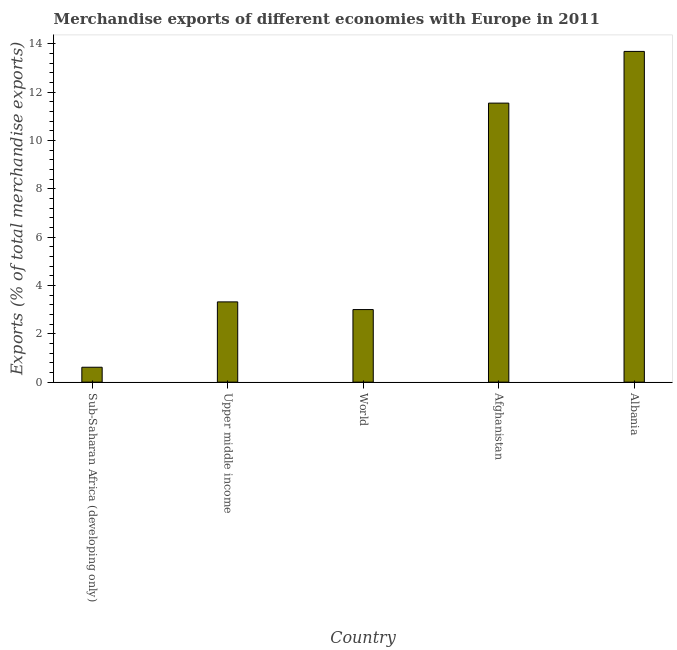Does the graph contain any zero values?
Give a very brief answer. No. What is the title of the graph?
Your answer should be very brief. Merchandise exports of different economies with Europe in 2011. What is the label or title of the X-axis?
Your response must be concise. Country. What is the label or title of the Y-axis?
Offer a terse response. Exports (% of total merchandise exports). What is the merchandise exports in Afghanistan?
Keep it short and to the point. 11.55. Across all countries, what is the maximum merchandise exports?
Ensure brevity in your answer.  13.69. Across all countries, what is the minimum merchandise exports?
Your response must be concise. 0.62. In which country was the merchandise exports maximum?
Your answer should be very brief. Albania. In which country was the merchandise exports minimum?
Provide a succinct answer. Sub-Saharan Africa (developing only). What is the sum of the merchandise exports?
Offer a very short reply. 32.17. What is the difference between the merchandise exports in Albania and World?
Provide a succinct answer. 10.68. What is the average merchandise exports per country?
Provide a succinct answer. 6.43. What is the median merchandise exports?
Your answer should be compact. 3.32. What is the ratio of the merchandise exports in Afghanistan to that in World?
Provide a succinct answer. 3.85. Is the difference between the merchandise exports in Albania and Upper middle income greater than the difference between any two countries?
Provide a short and direct response. No. What is the difference between the highest and the second highest merchandise exports?
Your answer should be very brief. 2.14. Is the sum of the merchandise exports in Afghanistan and World greater than the maximum merchandise exports across all countries?
Offer a very short reply. Yes. What is the difference between the highest and the lowest merchandise exports?
Give a very brief answer. 13.07. In how many countries, is the merchandise exports greater than the average merchandise exports taken over all countries?
Provide a succinct answer. 2. How many bars are there?
Your answer should be very brief. 5. What is the Exports (% of total merchandise exports) in Sub-Saharan Africa (developing only)?
Provide a short and direct response. 0.62. What is the Exports (% of total merchandise exports) of Upper middle income?
Give a very brief answer. 3.32. What is the Exports (% of total merchandise exports) of World?
Your response must be concise. 3. What is the Exports (% of total merchandise exports) in Afghanistan?
Offer a very short reply. 11.55. What is the Exports (% of total merchandise exports) in Albania?
Ensure brevity in your answer.  13.69. What is the difference between the Exports (% of total merchandise exports) in Sub-Saharan Africa (developing only) and Upper middle income?
Your answer should be compact. -2.7. What is the difference between the Exports (% of total merchandise exports) in Sub-Saharan Africa (developing only) and World?
Offer a terse response. -2.39. What is the difference between the Exports (% of total merchandise exports) in Sub-Saharan Africa (developing only) and Afghanistan?
Provide a short and direct response. -10.93. What is the difference between the Exports (% of total merchandise exports) in Sub-Saharan Africa (developing only) and Albania?
Your response must be concise. -13.07. What is the difference between the Exports (% of total merchandise exports) in Upper middle income and World?
Make the answer very short. 0.32. What is the difference between the Exports (% of total merchandise exports) in Upper middle income and Afghanistan?
Offer a very short reply. -8.22. What is the difference between the Exports (% of total merchandise exports) in Upper middle income and Albania?
Give a very brief answer. -10.36. What is the difference between the Exports (% of total merchandise exports) in World and Afghanistan?
Ensure brevity in your answer.  -8.54. What is the difference between the Exports (% of total merchandise exports) in World and Albania?
Provide a short and direct response. -10.68. What is the difference between the Exports (% of total merchandise exports) in Afghanistan and Albania?
Give a very brief answer. -2.14. What is the ratio of the Exports (% of total merchandise exports) in Sub-Saharan Africa (developing only) to that in Upper middle income?
Ensure brevity in your answer.  0.19. What is the ratio of the Exports (% of total merchandise exports) in Sub-Saharan Africa (developing only) to that in World?
Give a very brief answer. 0.2. What is the ratio of the Exports (% of total merchandise exports) in Sub-Saharan Africa (developing only) to that in Afghanistan?
Keep it short and to the point. 0.05. What is the ratio of the Exports (% of total merchandise exports) in Sub-Saharan Africa (developing only) to that in Albania?
Give a very brief answer. 0.04. What is the ratio of the Exports (% of total merchandise exports) in Upper middle income to that in World?
Provide a short and direct response. 1.11. What is the ratio of the Exports (% of total merchandise exports) in Upper middle income to that in Afghanistan?
Provide a short and direct response. 0.29. What is the ratio of the Exports (% of total merchandise exports) in Upper middle income to that in Albania?
Keep it short and to the point. 0.24. What is the ratio of the Exports (% of total merchandise exports) in World to that in Afghanistan?
Make the answer very short. 0.26. What is the ratio of the Exports (% of total merchandise exports) in World to that in Albania?
Make the answer very short. 0.22. What is the ratio of the Exports (% of total merchandise exports) in Afghanistan to that in Albania?
Provide a short and direct response. 0.84. 